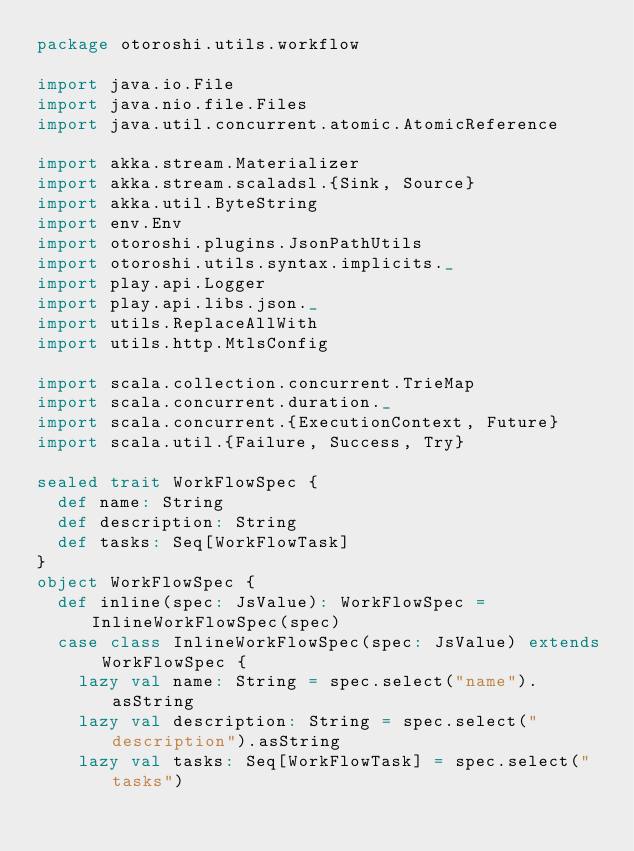<code> <loc_0><loc_0><loc_500><loc_500><_Scala_>package otoroshi.utils.workflow

import java.io.File
import java.nio.file.Files
import java.util.concurrent.atomic.AtomicReference

import akka.stream.Materializer
import akka.stream.scaladsl.{Sink, Source}
import akka.util.ByteString
import env.Env
import otoroshi.plugins.JsonPathUtils
import otoroshi.utils.syntax.implicits._
import play.api.Logger
import play.api.libs.json._
import utils.ReplaceAllWith
import utils.http.MtlsConfig

import scala.collection.concurrent.TrieMap
import scala.concurrent.duration._
import scala.concurrent.{ExecutionContext, Future}
import scala.util.{Failure, Success, Try}

sealed trait WorkFlowSpec {
  def name: String
  def description: String
  def tasks: Seq[WorkFlowTask]
}
object WorkFlowSpec {
  def inline(spec: JsValue): WorkFlowSpec = InlineWorkFlowSpec(spec)
  case class InlineWorkFlowSpec(spec: JsValue) extends WorkFlowSpec {
    lazy val name: String = spec.select("name").asString
    lazy val description: String = spec.select("description").asString
    lazy val tasks: Seq[WorkFlowTask] = spec.select("tasks")</code> 